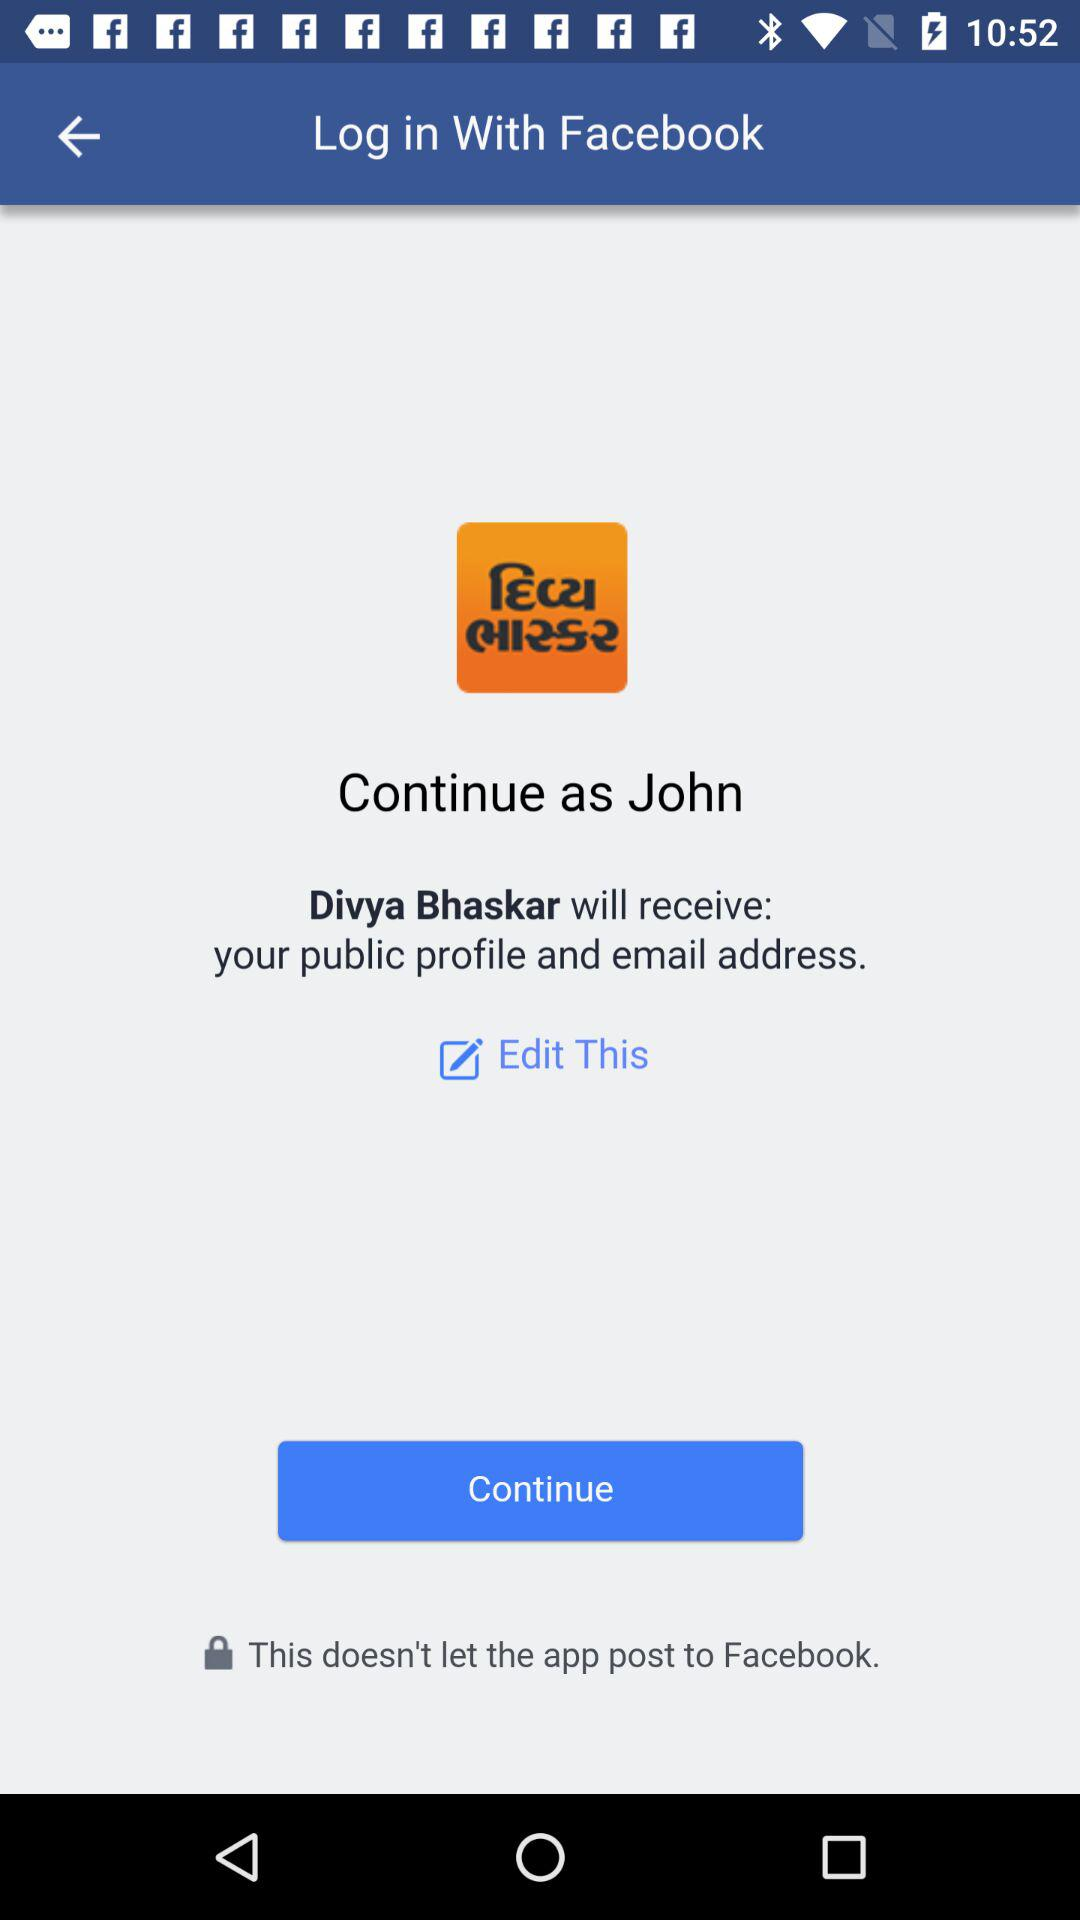What application is asking for permission? The application asking for permission is "Divya Bhaskar". 